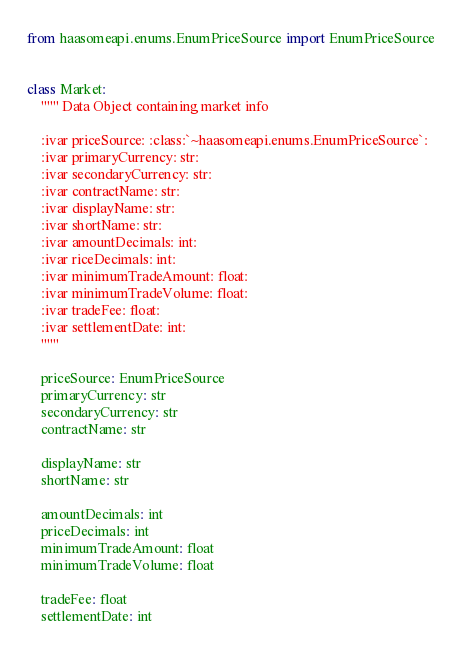Convert code to text. <code><loc_0><loc_0><loc_500><loc_500><_Python_>from haasomeapi.enums.EnumPriceSource import EnumPriceSource


class Market:
    """ Data Object containing market info

    :ivar priceSource: :class:`~haasomeapi.enums.EnumPriceSource`: 
    :ivar primaryCurrency: str:
    :ivar secondaryCurrency: str:
    :ivar contractName: str:
    :ivar displayName: str:
    :ivar shortName: str:
    :ivar amountDecimals: int:
    :ivar riceDecimals: int:
    :ivar minimumTradeAmount: float:
    :ivar minimumTradeVolume: float:
    :ivar tradeFee: float:
    :ivar settlementDate: int:
    """

    priceSource: EnumPriceSource
    primaryCurrency: str
    secondaryCurrency: str
    contractName: str

    displayName: str
    shortName: str

    amountDecimals: int
    priceDecimals: int
    minimumTradeAmount: float
    minimumTradeVolume: float

    tradeFee: float
    settlementDate: int
</code> 